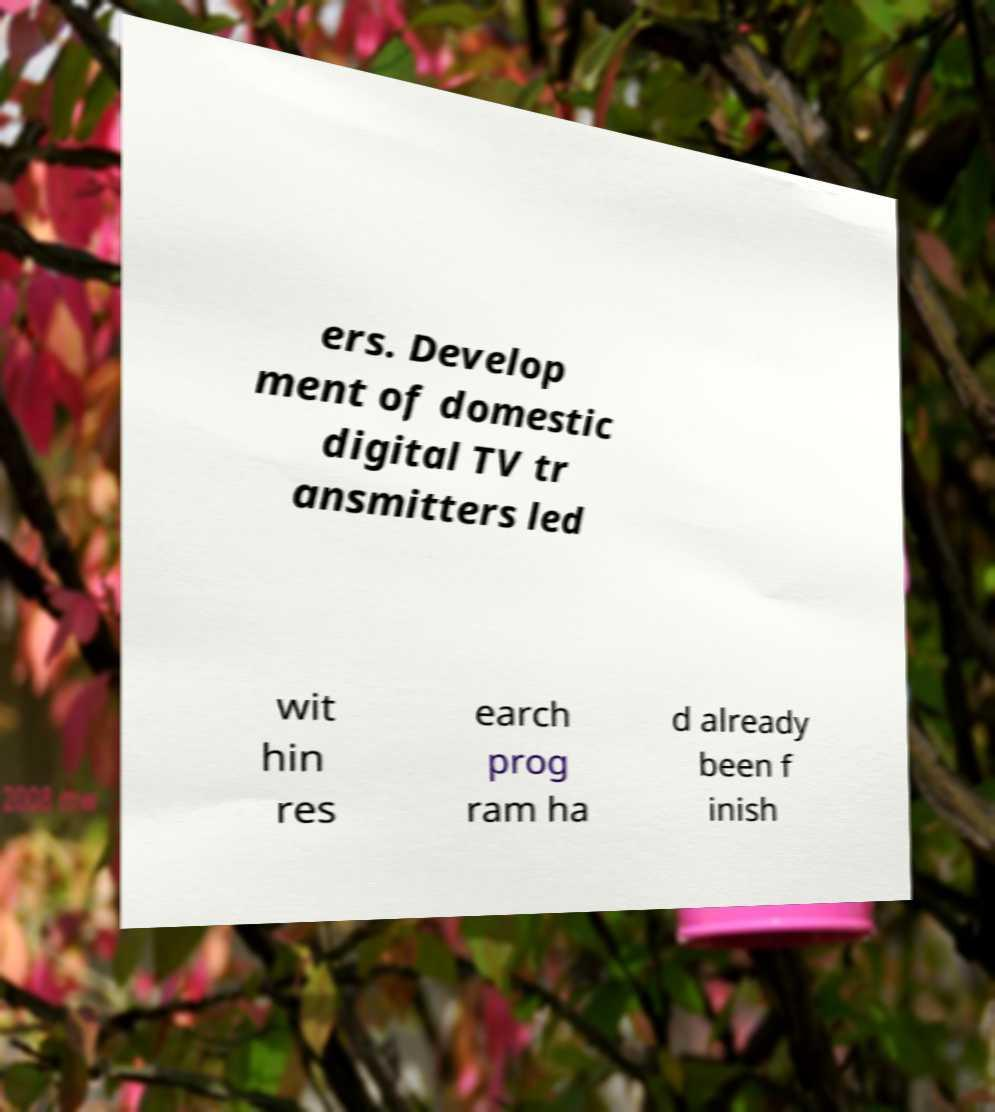What messages or text are displayed in this image? I need them in a readable, typed format. ers. Develop ment of domestic digital TV tr ansmitters led wit hin res earch prog ram ha d already been f inish 